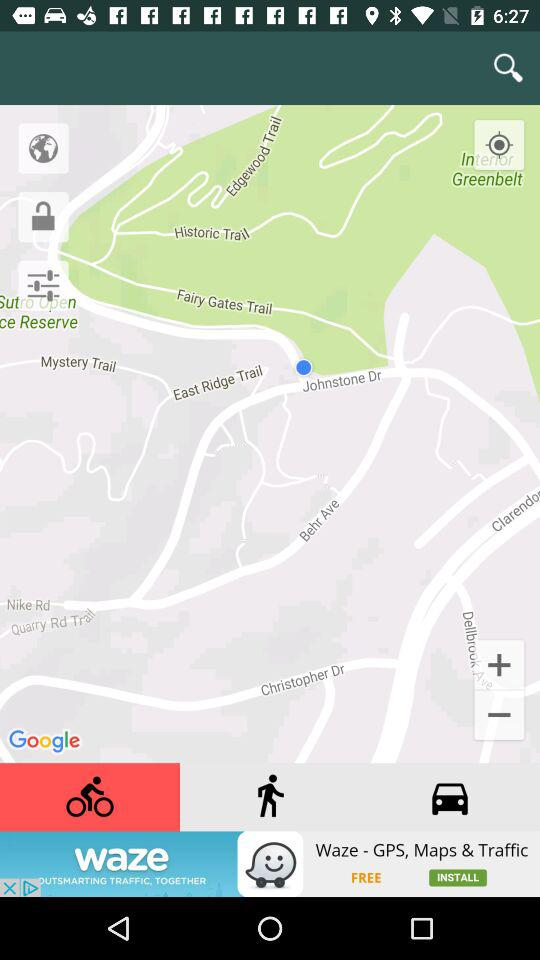What is the current location? The current location is Medical Center Way, San Francisco, CA 94131, USA. 